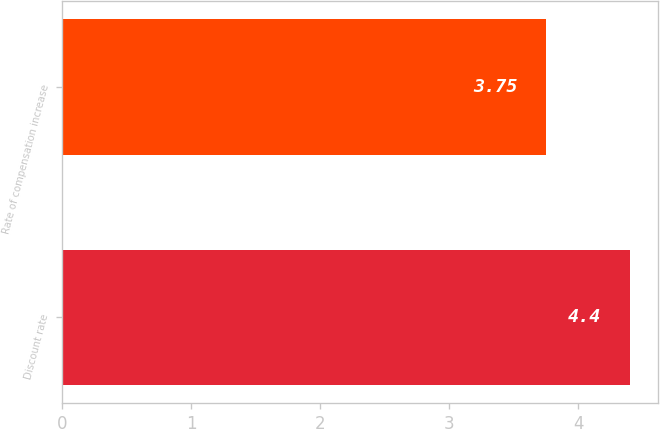<chart> <loc_0><loc_0><loc_500><loc_500><bar_chart><fcel>Discount rate<fcel>Rate of compensation increase<nl><fcel>4.4<fcel>3.75<nl></chart> 